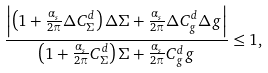Convert formula to latex. <formula><loc_0><loc_0><loc_500><loc_500>\frac { \left | \left ( 1 + \frac { \alpha _ { s } } { 2 \pi } \Delta C ^ { d } _ { \Sigma } \right ) \Delta \Sigma + \frac { \alpha _ { s } } { 2 \pi } \Delta C ^ { d } _ { g } \Delta g \right | } { \left ( 1 + \frac { \alpha _ { s } } { 2 \pi } C ^ { d } _ { \Sigma } \right ) \Sigma + \frac { \alpha _ { s } } { 2 \pi } C ^ { d } _ { g } g } \leq 1 ,</formula> 